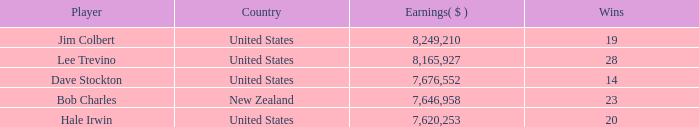How many players named bob charles with earnings over $7,646,958? 0.0. 